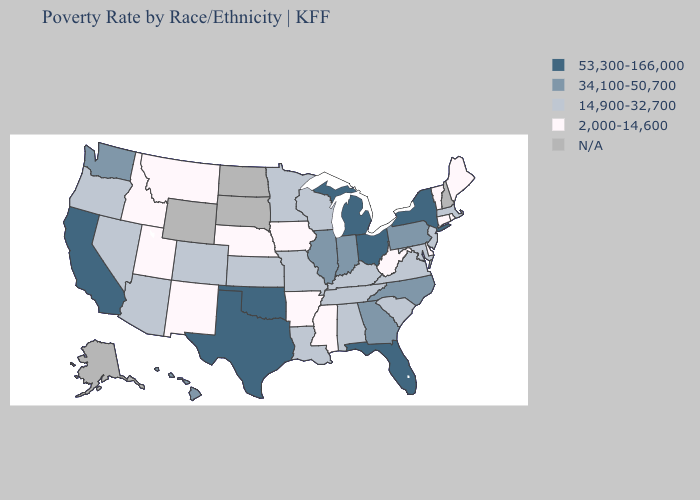What is the value of Florida?
Quick response, please. 53,300-166,000. What is the lowest value in states that border Kentucky?
Quick response, please. 2,000-14,600. Among the states that border Texas , which have the lowest value?
Concise answer only. Arkansas, New Mexico. What is the value of Minnesota?
Write a very short answer. 14,900-32,700. Does Delaware have the lowest value in the South?
Quick response, please. Yes. What is the highest value in the Northeast ?
Be succinct. 53,300-166,000. What is the value of Montana?
Keep it brief. 2,000-14,600. Which states have the lowest value in the USA?
Write a very short answer. Arkansas, Connecticut, Delaware, Idaho, Iowa, Maine, Mississippi, Montana, Nebraska, New Mexico, Rhode Island, Utah, Vermont, West Virginia. Which states have the lowest value in the USA?
Short answer required. Arkansas, Connecticut, Delaware, Idaho, Iowa, Maine, Mississippi, Montana, Nebraska, New Mexico, Rhode Island, Utah, Vermont, West Virginia. Does the first symbol in the legend represent the smallest category?
Short answer required. No. What is the value of Utah?
Be succinct. 2,000-14,600. Which states have the highest value in the USA?
Write a very short answer. California, Florida, Michigan, New York, Ohio, Oklahoma, Texas. Among the states that border Utah , which have the lowest value?
Be succinct. Idaho, New Mexico. Name the states that have a value in the range 34,100-50,700?
Give a very brief answer. Georgia, Hawaii, Illinois, Indiana, North Carolina, Pennsylvania, Washington. 